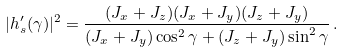Convert formula to latex. <formula><loc_0><loc_0><loc_500><loc_500>| h ^ { \prime } _ { s } ( \gamma ) | ^ { 2 } = \frac { ( J _ { x } + J _ { z } ) ( J _ { x } + J _ { y } ) ( J _ { z } + J _ { y } ) } { ( J _ { x } + J _ { y } ) \cos ^ { 2 } \gamma + ( J _ { z } + J _ { y } ) \sin ^ { 2 } \gamma } \, .</formula> 